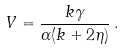<formula> <loc_0><loc_0><loc_500><loc_500>V = \frac { k \gamma } { \alpha ( k + 2 \eta ) } \, .</formula> 